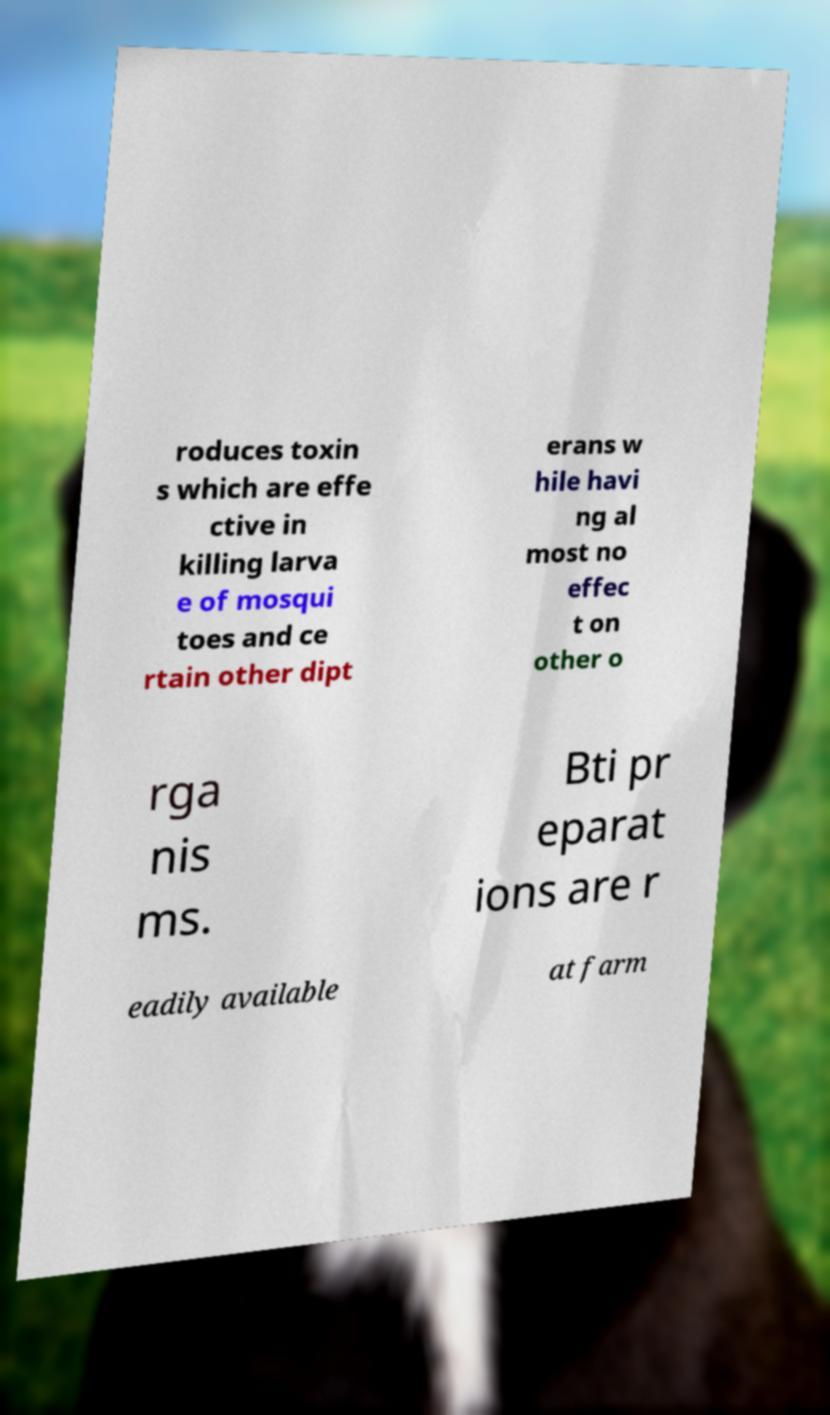Can you read and provide the text displayed in the image?This photo seems to have some interesting text. Can you extract and type it out for me? roduces toxin s which are effe ctive in killing larva e of mosqui toes and ce rtain other dipt erans w hile havi ng al most no effec t on other o rga nis ms. Bti pr eparat ions are r eadily available at farm 